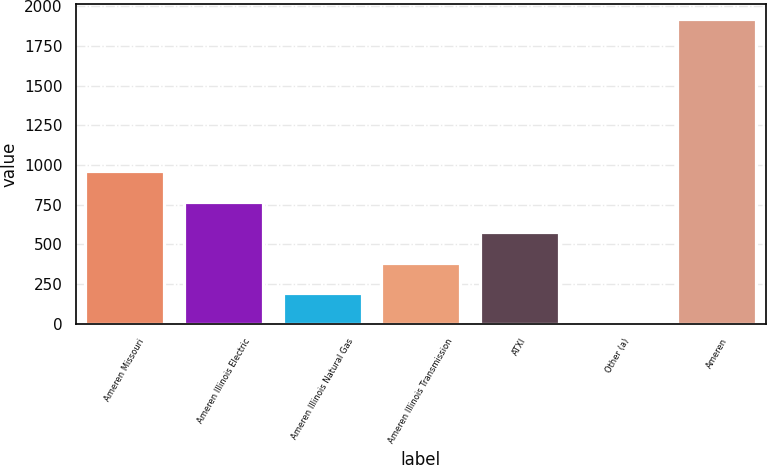<chart> <loc_0><loc_0><loc_500><loc_500><bar_chart><fcel>Ameren Missouri<fcel>Ameren Illinois Electric<fcel>Ameren Illinois Natural Gas<fcel>Ameren Illinois Transmission<fcel>ATXI<fcel>Other (a)<fcel>Ameren<nl><fcel>959.5<fcel>768<fcel>193.5<fcel>385<fcel>576.5<fcel>2<fcel>1917<nl></chart> 